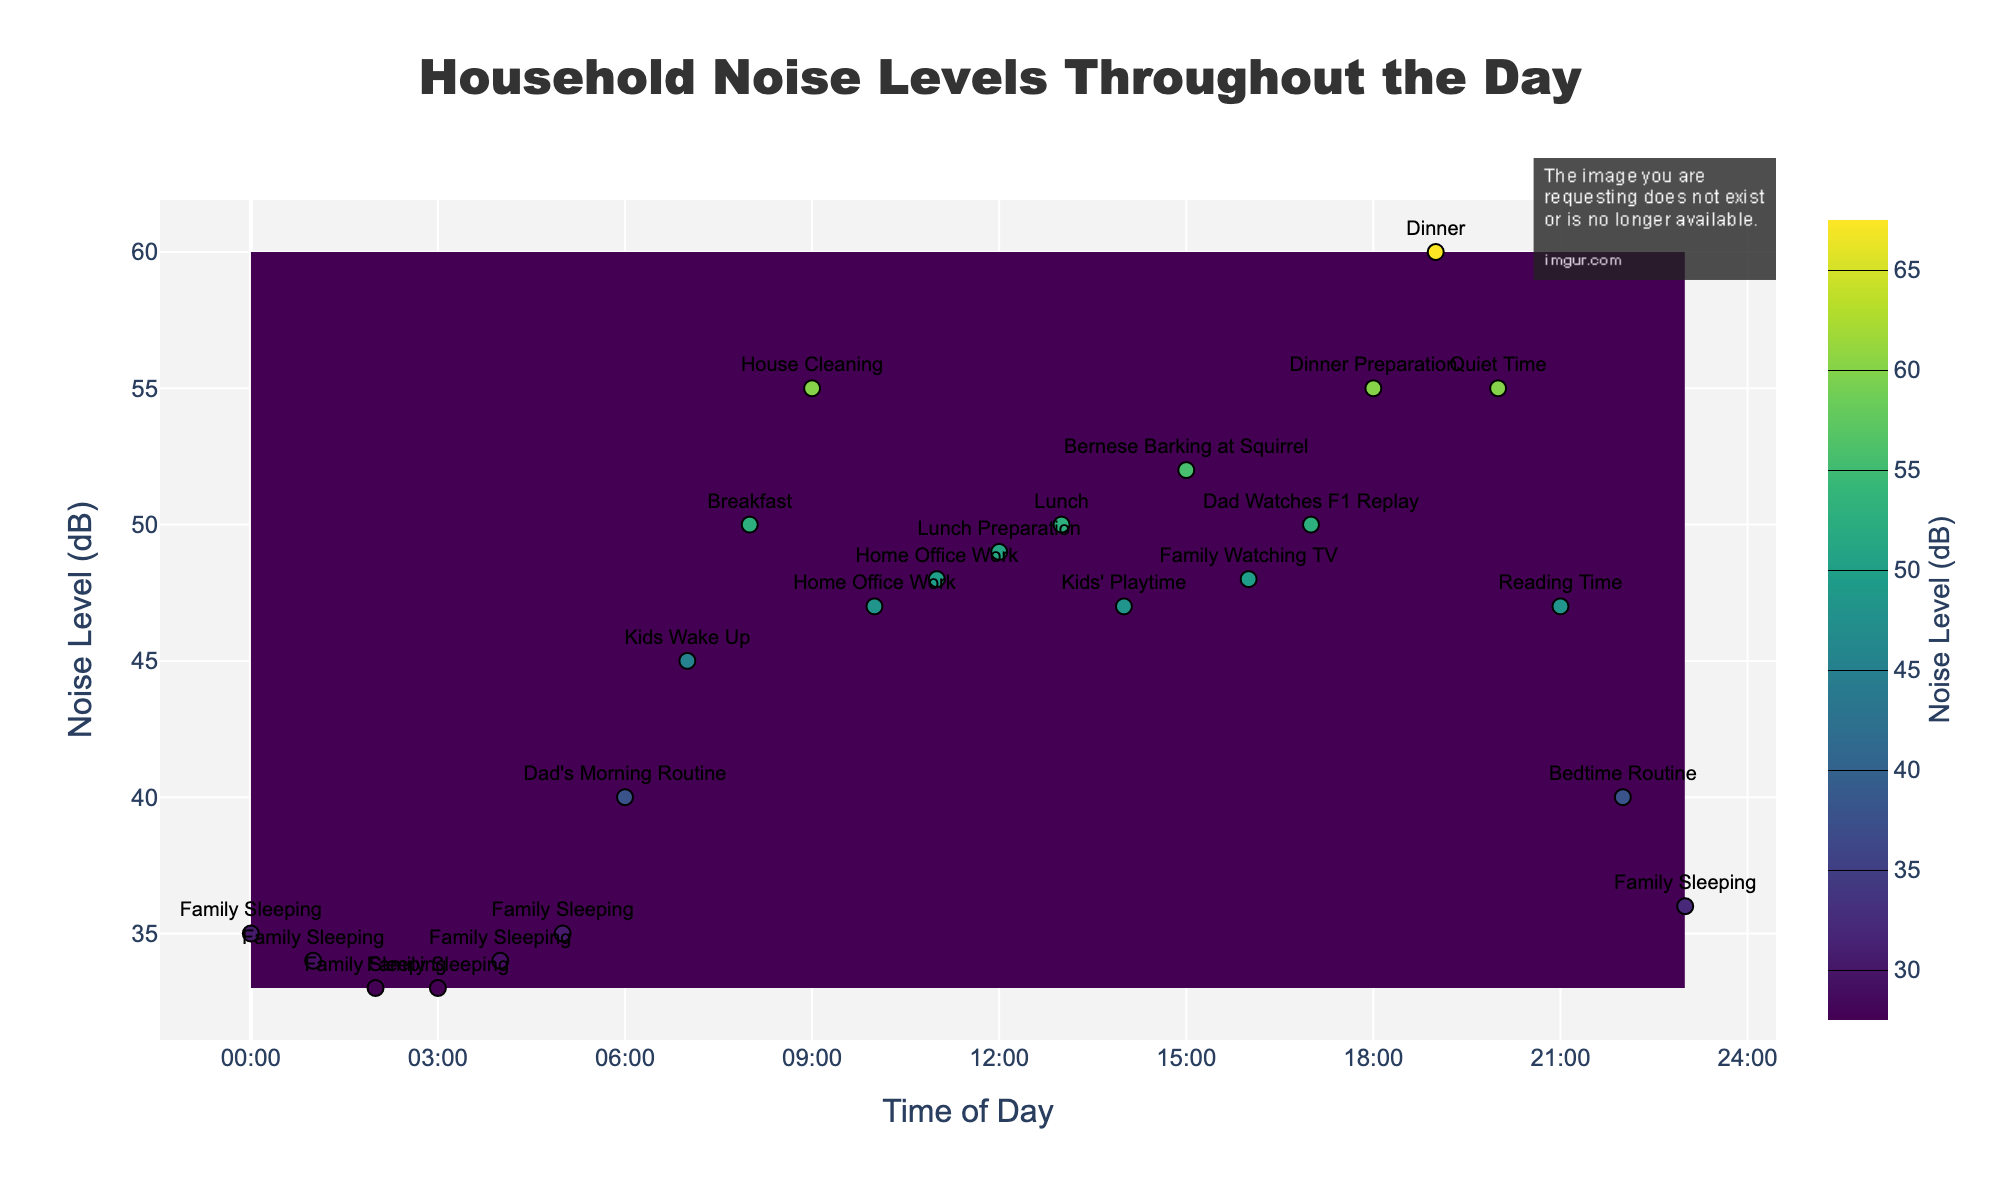What's the title of the figure? The title is located at the top of the figure.
Answer: Household Noise Levels Throughout the Day What does the color represent in the contour plot? The color represents different noise levels in decibels (dB) as indicated by the color scale on the right side of the plot.
Answer: Noise levels in dB At what time of day does the noise level peak at 60 dB? Examine the labels on the x-axis (time) and find the peak at 60 dB on the y-axis, marked by a specific activity label. The peak at 60 dB corresponds to the label "Dinner" around 19:00.
Answer: 19:00 What is the activity associated with the lowest noise level? Look for the lowest noise level on the y-axis, which is 33 dB, and its corresponding labels on the plot. The activity is "Family Sleeping" at 02:00 and 03:00.
Answer: Family Sleeping Compare the noise levels during "Breakfast" and "Dinner". Which one is louder? Find the noise levels corresponding to "Breakfast" and "Dinner" labels by looking at their positions on the x and y axes. "Breakfast" at 08:00 is 50 dB, while "Dinner" at 19:00 is 60 dB.
Answer: Dinner During "Dad's Morning Routine" and "Dad Watches F1 Replay", what are the noise levels, and which activity is noisier? Identify the noise levels for "Dad's Morning Routine" at 06:00 (40 dB) and "Dad Watches F1 Replay" at 17:00 (50 dB). "Dad Watches F1 Replay" is noisier.
Answer: Dad Watches F1 Replay What time range shows the "Family Sleeping" activity, and what are the noise levels during these hours? Locate the "Family Sleeping" labels on the plot and note their time range and corresponding noise levels. "Family Sleeping" occurs from 00:00 - 05:00 and at 23:00, with noise levels between 33-36 dB at these times.
Answer: 00:00 - 05:00 and 23:00, noise levels 33-36 dB How does the noise level change from "Breakfast" to "House Cleaning"? Compare the noise level increase from 50 dB ("Breakfast" at 08:00) to 55 dB ("House Cleaning" at 09:00). The plot shows an increase of 5 dB.
Answer: Increases by 5 dB 